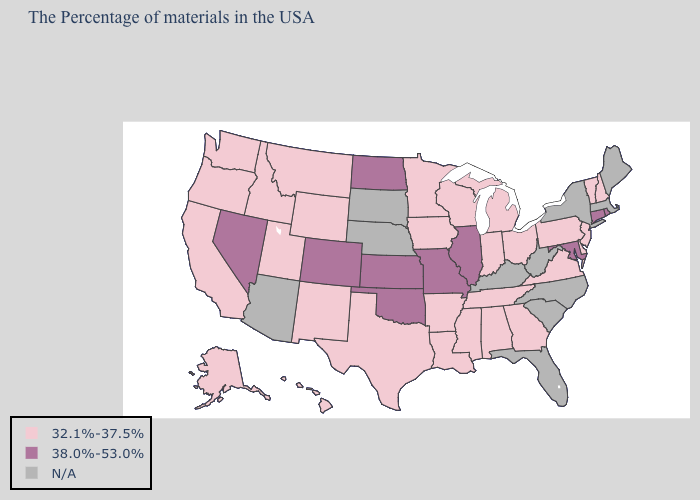What is the lowest value in states that border Oregon?
Quick response, please. 32.1%-37.5%. What is the lowest value in states that border Washington?
Write a very short answer. 32.1%-37.5%. What is the value of California?
Quick response, please. 32.1%-37.5%. Name the states that have a value in the range 32.1%-37.5%?
Answer briefly. New Hampshire, Vermont, New Jersey, Delaware, Pennsylvania, Virginia, Ohio, Georgia, Michigan, Indiana, Alabama, Tennessee, Wisconsin, Mississippi, Louisiana, Arkansas, Minnesota, Iowa, Texas, Wyoming, New Mexico, Utah, Montana, Idaho, California, Washington, Oregon, Alaska, Hawaii. What is the value of Maine?
Write a very short answer. N/A. Which states hav the highest value in the South?
Write a very short answer. Maryland, Oklahoma. What is the value of Texas?
Answer briefly. 32.1%-37.5%. Is the legend a continuous bar?
Be succinct. No. What is the value of New Mexico?
Write a very short answer. 32.1%-37.5%. Name the states that have a value in the range N/A?
Be succinct. Maine, Massachusetts, New York, North Carolina, South Carolina, West Virginia, Florida, Kentucky, Nebraska, South Dakota, Arizona. What is the value of California?
Short answer required. 32.1%-37.5%. How many symbols are there in the legend?
Keep it brief. 3. What is the value of Alaska?
Answer briefly. 32.1%-37.5%. 